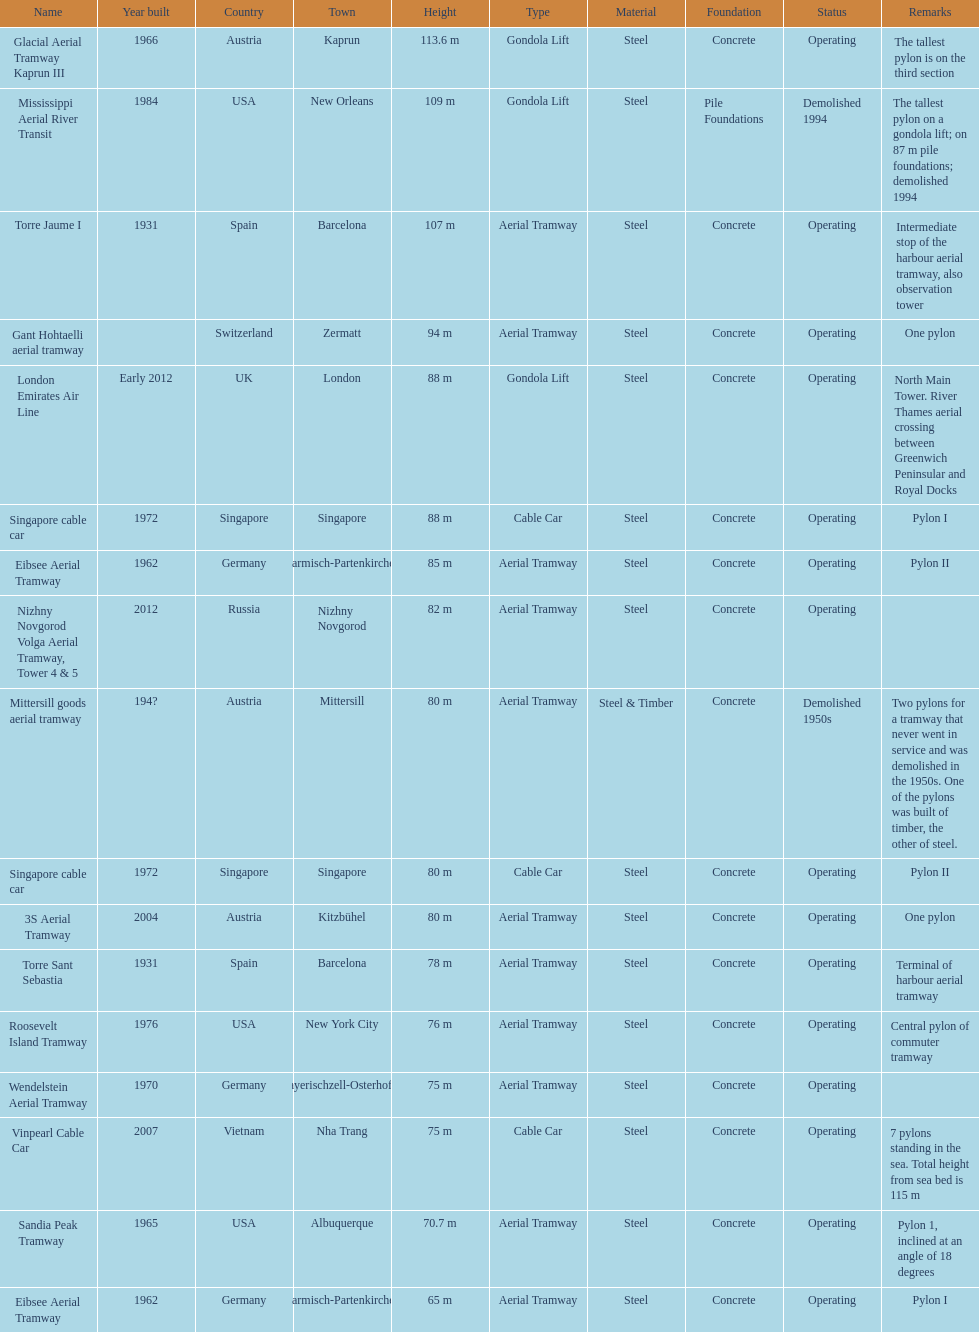Which pylon has the most remarks about it? Mittersill goods aerial tramway. 